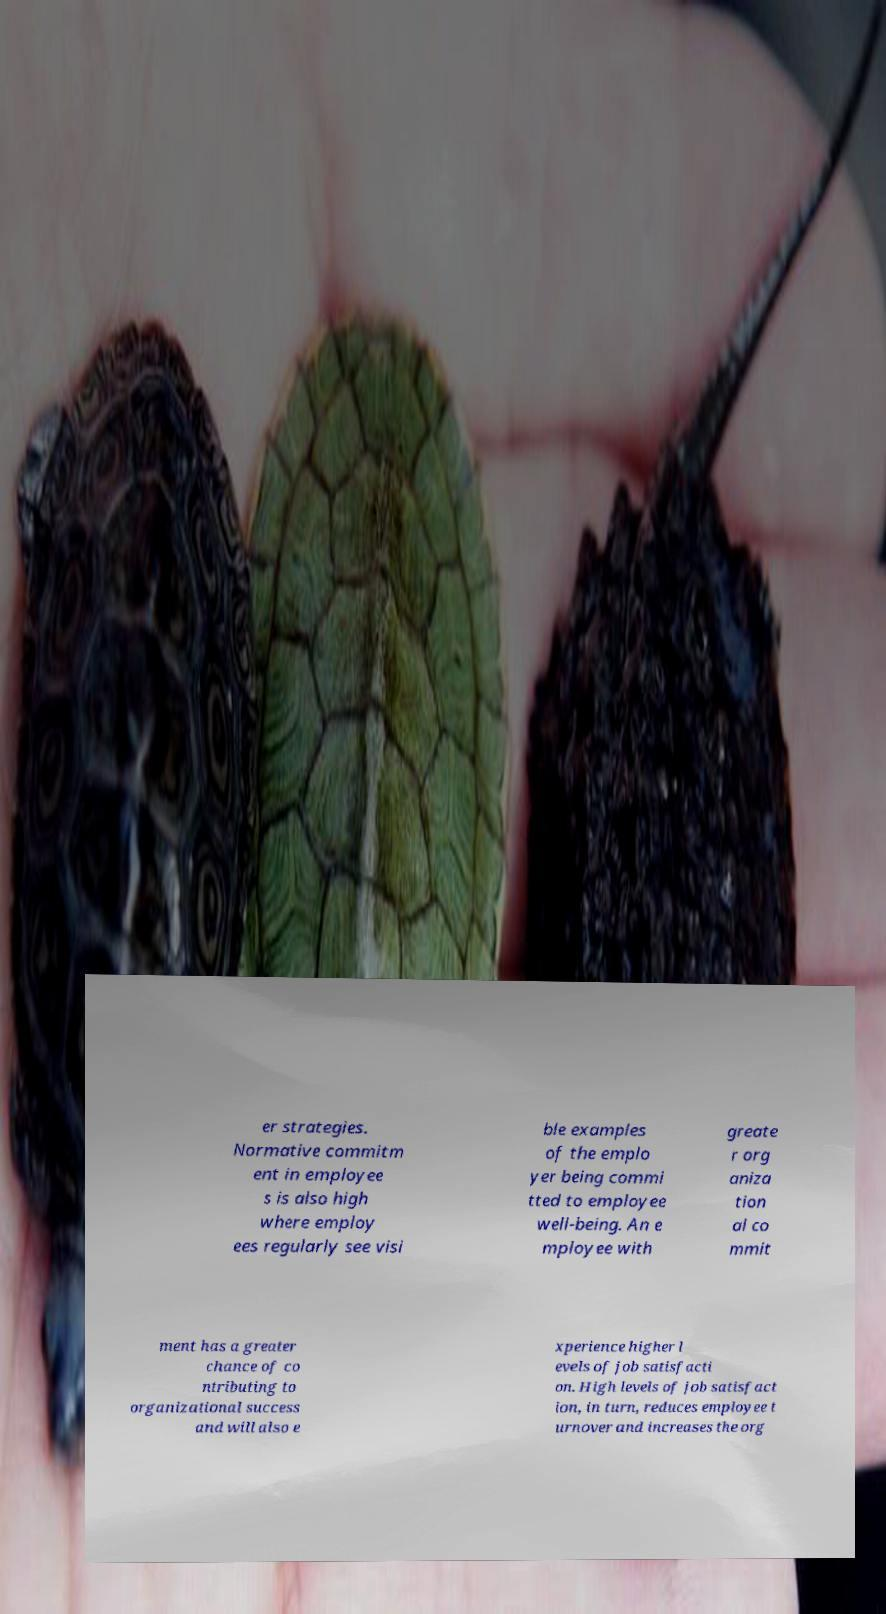What messages or text are displayed in this image? I need them in a readable, typed format. er strategies. Normative commitm ent in employee s is also high where employ ees regularly see visi ble examples of the emplo yer being commi tted to employee well-being. An e mployee with greate r org aniza tion al co mmit ment has a greater chance of co ntributing to organizational success and will also e xperience higher l evels of job satisfacti on. High levels of job satisfact ion, in turn, reduces employee t urnover and increases the org 